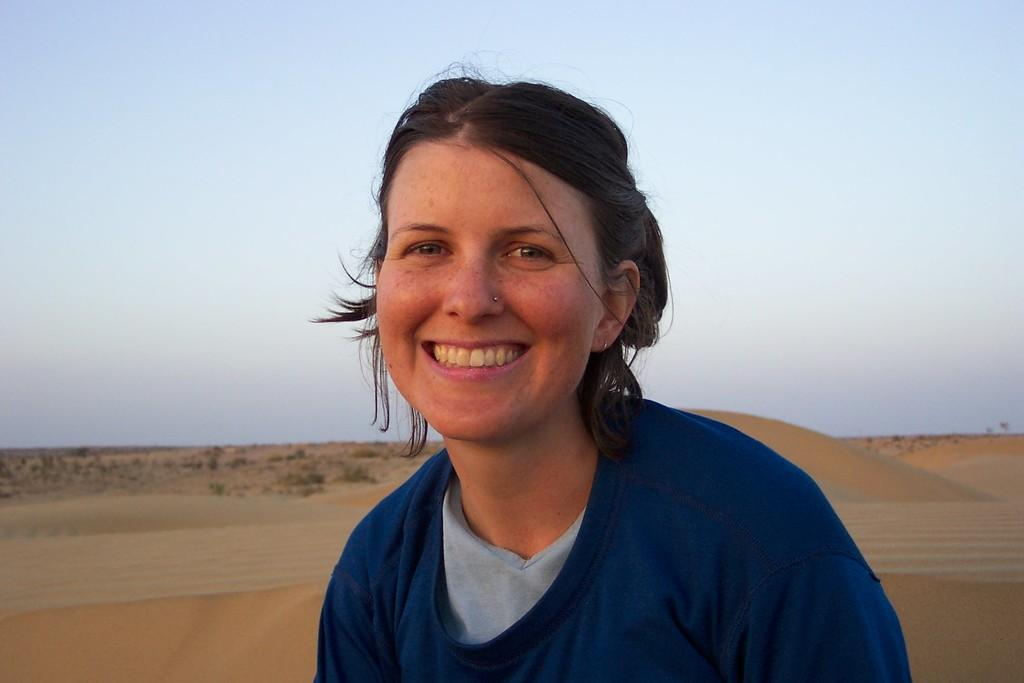Who or what is the main subject in the image? There is a person in the image. What is the person wearing? The person is wearing a blue dress. What can be seen in the background of the image? The background of the image includes sand in brown color and the blue sky. What shape is the rabbit making in the sand in the image? There is no rabbit present in the image, so it is not possible to determine the shape it might be making in the sand. 